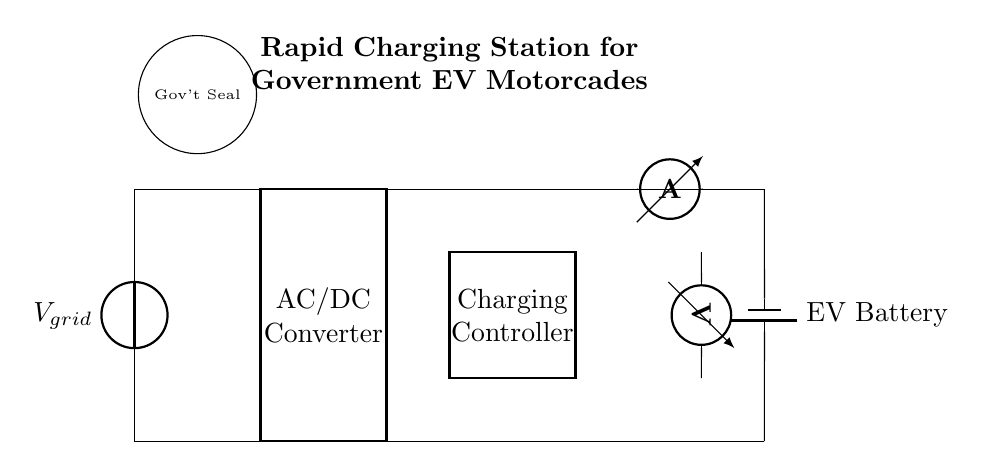What is the type of power source in the circuit? The circuit includes a power source labeled as a grid voltage. The symbol represents an alternating current source, generally used for supplying energy to the system.
Answer: Grid voltage What component converts AC to DC in this circuit? The AC/DC Converter is a specific component shown in the circuit. This device's role is to change alternating current into direct current, which is essential for charging electric vehicle batteries.
Answer: AC/DC Converter Where is the charging controller located in the diagram? The Charging Controller is represented as a rectangle labeled in the circuit. Its position can be identified between the DC Bus and the electric vehicle battery, signifying its role in regulating charging parameters.
Answer: Between the DC Bus and EV Battery How many sensors are present in the circuit? The circuit includes two types of sensors: a Current Sensor and a Voltage Sensor. By counting the distinct symbols representing them, it is confirmed that both types are included.
Answer: Two What function does the current sensor serve in this charging station? The current sensor measures the flow of electric current in the circuit. It helps monitor how much current is being delivered to the electric vehicle battery, ensuring that it is within safe operating levels.
Answer: Monitors current flow Which component connects to the electric vehicle battery in the circuit? The electric vehicle battery is connected to the DC Bus, representing the storage unit for the electric vehicle’s energy needs. Its positioning shows it is the final component receiving energy from the charging station.
Answer: DC Bus What is the purpose of the government seal in the diagram? The government seal signifies that the circuit and charging station are officially designated for government use, possibly indicating compliance with regulations or standards pertinent to public service vehicles.
Answer: Indicates government use 